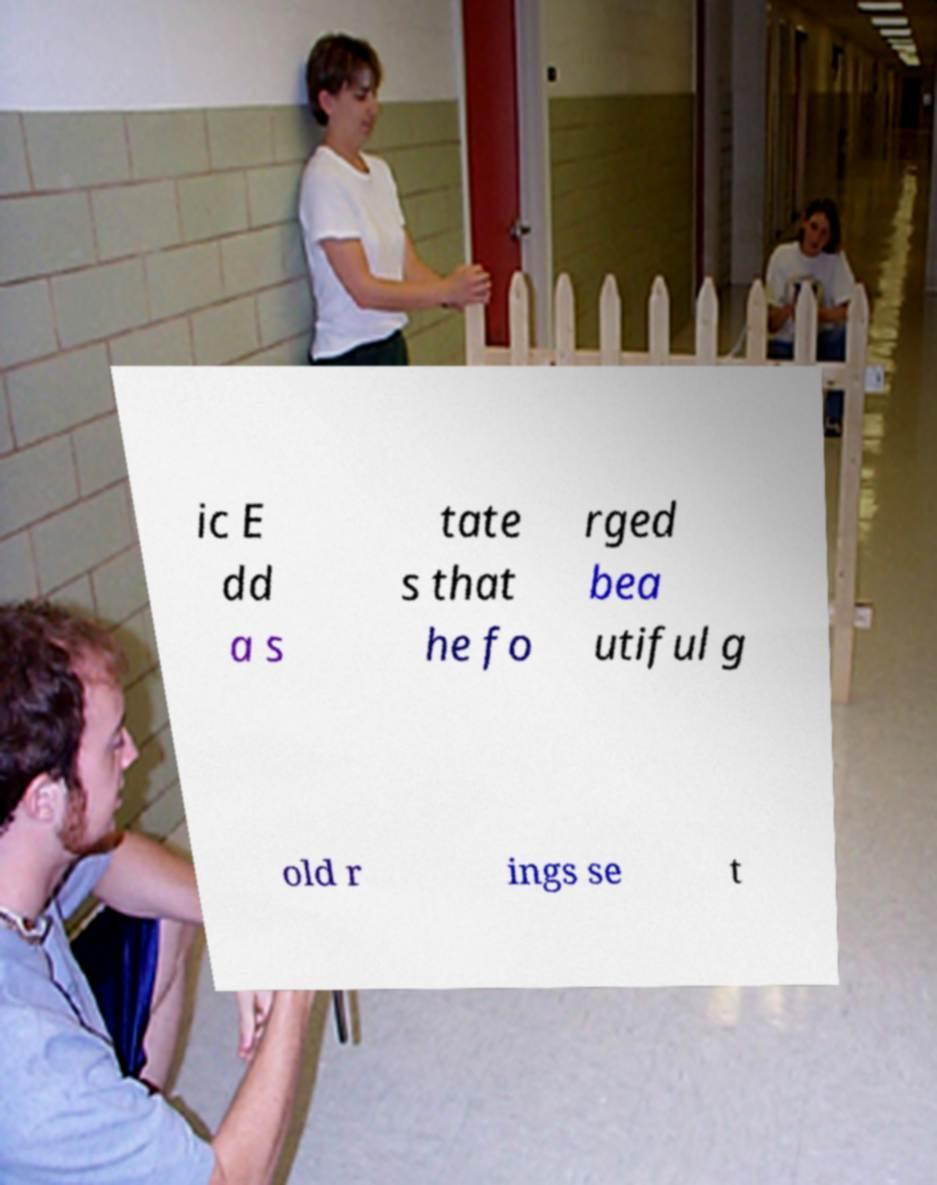Can you read and provide the text displayed in the image?This photo seems to have some interesting text. Can you extract and type it out for me? ic E dd a s tate s that he fo rged bea utiful g old r ings se t 